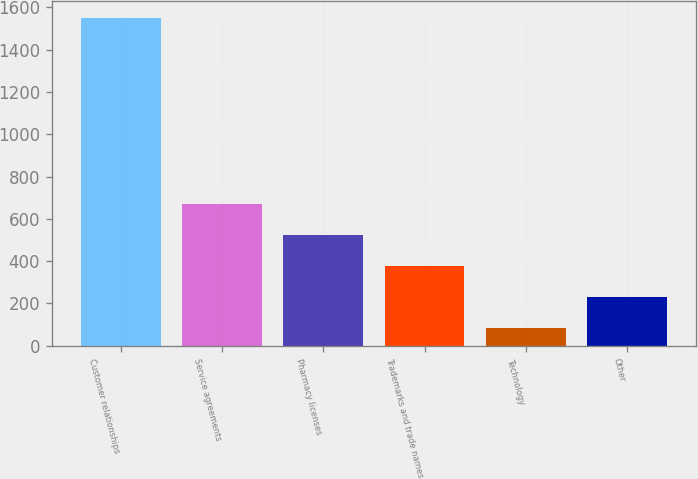<chart> <loc_0><loc_0><loc_500><loc_500><bar_chart><fcel>Customer relationships<fcel>Service agreements<fcel>Pharmacy licenses<fcel>Trademarks and trade names<fcel>Technology<fcel>Other<nl><fcel>1550<fcel>670.4<fcel>523.8<fcel>377.2<fcel>84<fcel>230.6<nl></chart> 